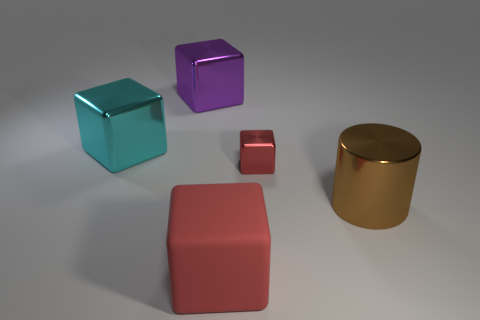Add 1 purple shiny blocks. How many objects exist? 6 Subtract all cylinders. How many objects are left? 4 Subtract all blocks. Subtract all big green rubber cylinders. How many objects are left? 1 Add 3 big metallic objects. How many big metallic objects are left? 6 Add 4 cyan cylinders. How many cyan cylinders exist? 4 Subtract 0 yellow cylinders. How many objects are left? 5 